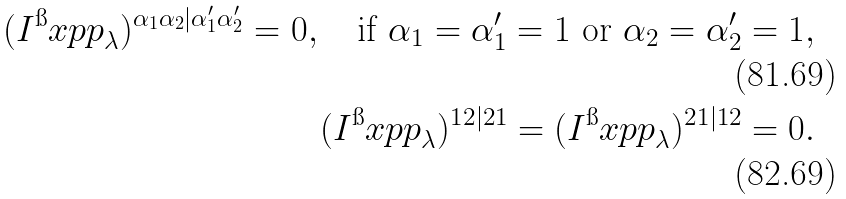Convert formula to latex. <formula><loc_0><loc_0><loc_500><loc_500>( I ^ { \i } x { p p } _ { \lambda } ) ^ { \alpha _ { 1 } \alpha _ { 2 } | \alpha ^ { \prime } _ { 1 } \alpha ^ { \prime } _ { 2 } } = 0 , \quad \text {if $\alpha_{1} = \alpha^{\prime}_{1} = 1$ or $\alpha_{2} = \alpha^{\prime}_{2}     = 1$} , \\ ( I ^ { \i } x { p p } _ { \lambda } ) ^ { 1 2 | 2 1 } = ( I ^ { \i } x { p p } _ { \lambda } ) ^ { 2 1 | 1 2 } = 0 .</formula> 